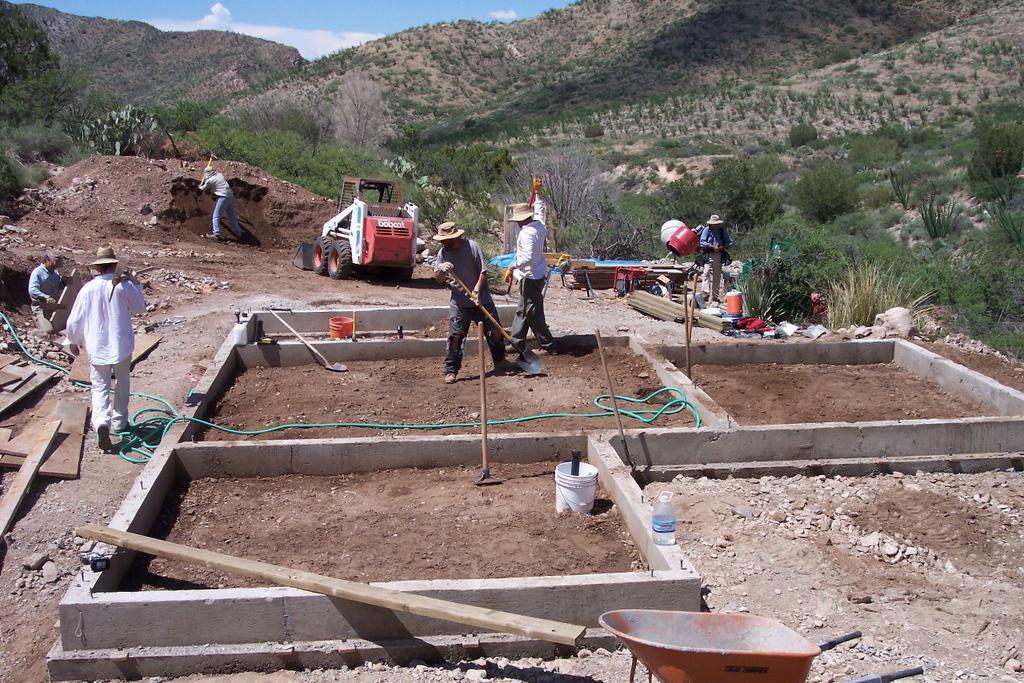Can you describe this image briefly? In this picture I can see there are few people constructing a building and they are holding tools, there is a wooden plank, water pipe, bucket, water bottle and there is soil on the floor. The people are wearing hats, shirts and pants. They are holding tools and the person on to left is walking and he is holding a tool in his hand. There are few wooden planks on the floor on to left. There is a man sitting and holding a wooden plank and there is another person at the soil and he is also holding tool. There is a red color vehicle and there are few others standing on the right. There are plants, trees and in the backdrop there are mountains and they are covered with trees and the sky is clear. 